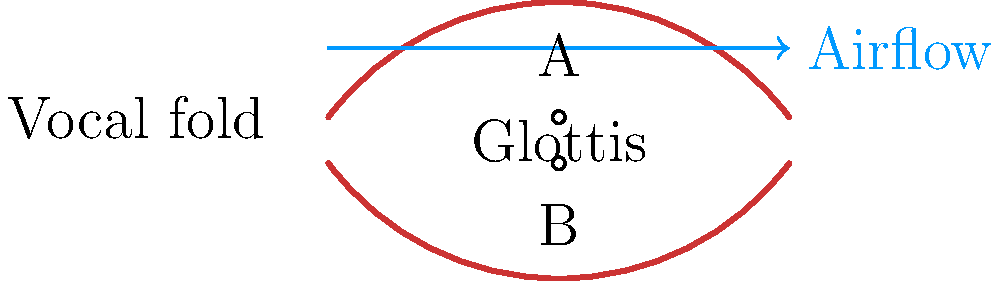During Nick Jonas's powerful high notes in "Jealous," which point (A or B) in the cross-sectional diagram of his vocal cords experiences higher pressure, and why is this crucial for his signature falsetto? To understand the biomechanics of Nick Jonas's vocal cords during singing, especially for his high notes in "Jealous," we need to consider the following:

1. Vocal cord anatomy: The diagram shows a cross-section of the vocal cords, with point A on the upper surface and point B in the glottis (space between the cords).

2. Bernoulli effect: As air flows through the narrow glottis, it speeds up, creating a pressure drop.

3. Pressure difference: Due to the Bernoulli effect, point B experiences lower pressure than point A.

4. Vocal cord vibration: The pressure difference causes the vocal cords to be drawn together, creating vibrations.

5. Falsetto production: For Nick's signature falsetto, the vocal cords are stretched thin and vibrate at a higher frequency.

6. Sound quality: The rapid opening and closing of the glottis, facilitated by this pressure difference, produces Nick's clear, high-pitched tone.

7. Vocal control: Nick's ability to maintain this delicate pressure balance allows him to sustain those impressive high notes.

Therefore, point A experiences higher pressure, which is crucial for creating the vibrations necessary for Nick's falsetto in "Jealous."
Answer: Point A; higher pressure creates vocal cord vibrations for falsetto. 